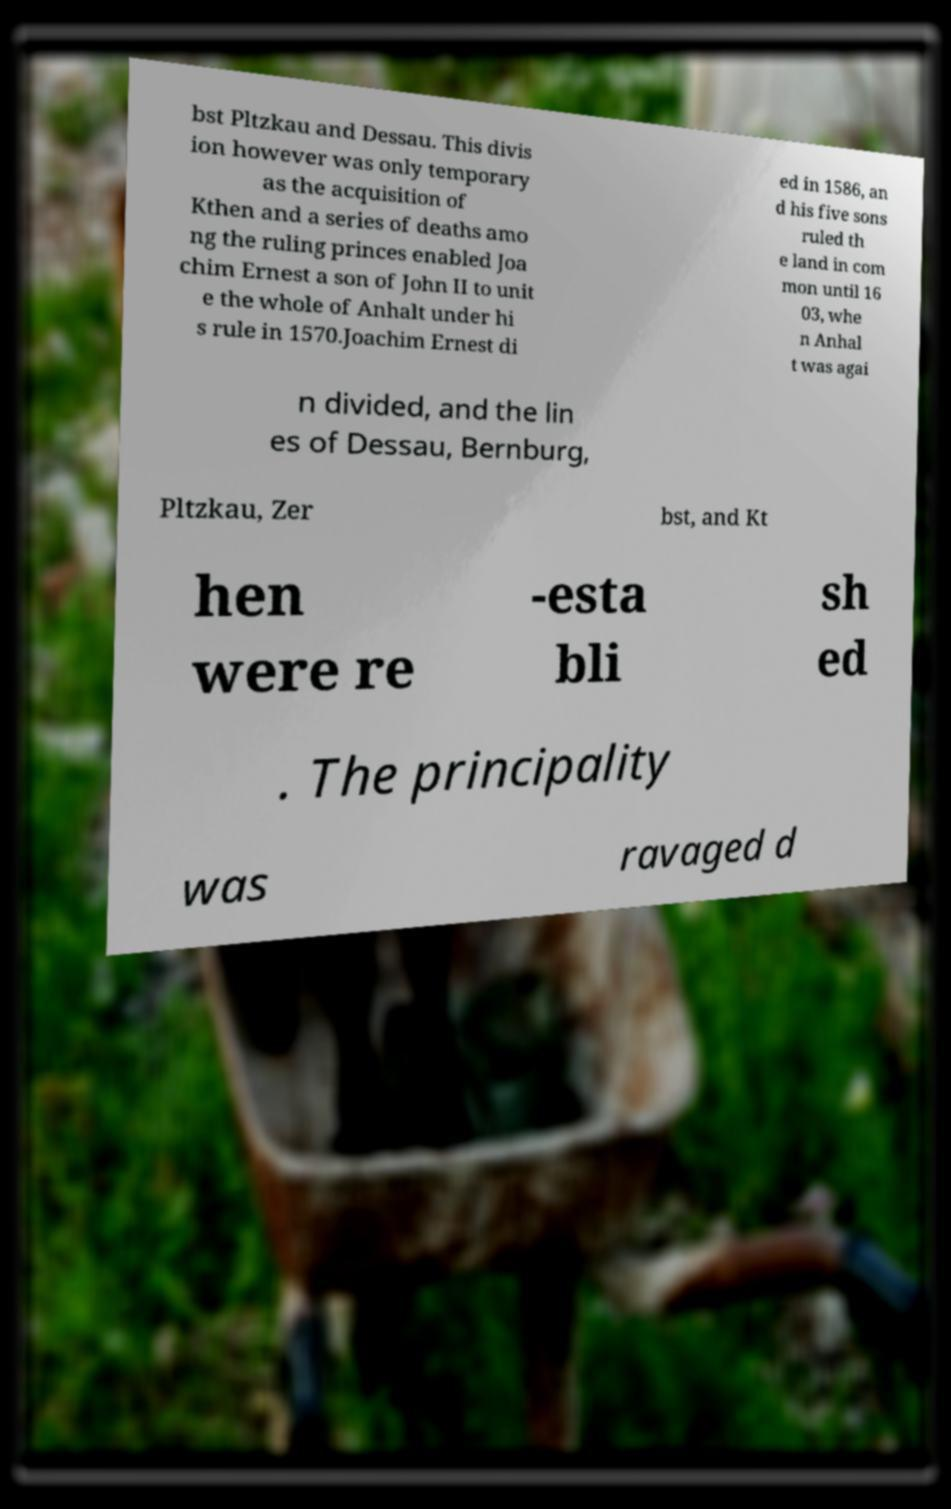Please read and relay the text visible in this image. What does it say? bst Pltzkau and Dessau. This divis ion however was only temporary as the acquisition of Kthen and a series of deaths amo ng the ruling princes enabled Joa chim Ernest a son of John II to unit e the whole of Anhalt under hi s rule in 1570.Joachim Ernest di ed in 1586, an d his five sons ruled th e land in com mon until 16 03, whe n Anhal t was agai n divided, and the lin es of Dessau, Bernburg, Pltzkau, Zer bst, and Kt hen were re -esta bli sh ed . The principality was ravaged d 